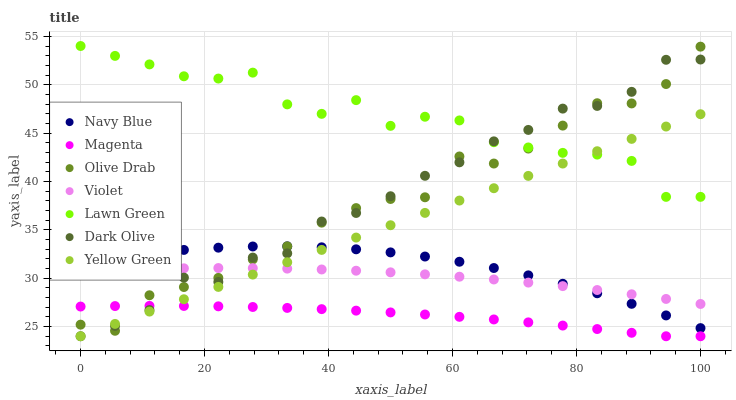Does Magenta have the minimum area under the curve?
Answer yes or no. Yes. Does Lawn Green have the maximum area under the curve?
Answer yes or no. Yes. Does Yellow Green have the minimum area under the curve?
Answer yes or no. No. Does Yellow Green have the maximum area under the curve?
Answer yes or no. No. Is Yellow Green the smoothest?
Answer yes or no. Yes. Is Lawn Green the roughest?
Answer yes or no. Yes. Is Navy Blue the smoothest?
Answer yes or no. No. Is Navy Blue the roughest?
Answer yes or no. No. Does Yellow Green have the lowest value?
Answer yes or no. Yes. Does Navy Blue have the lowest value?
Answer yes or no. No. Does Lawn Green have the highest value?
Answer yes or no. Yes. Does Yellow Green have the highest value?
Answer yes or no. No. Is Violet less than Lawn Green?
Answer yes or no. Yes. Is Lawn Green greater than Navy Blue?
Answer yes or no. Yes. Does Dark Olive intersect Magenta?
Answer yes or no. Yes. Is Dark Olive less than Magenta?
Answer yes or no. No. Is Dark Olive greater than Magenta?
Answer yes or no. No. Does Violet intersect Lawn Green?
Answer yes or no. No. 